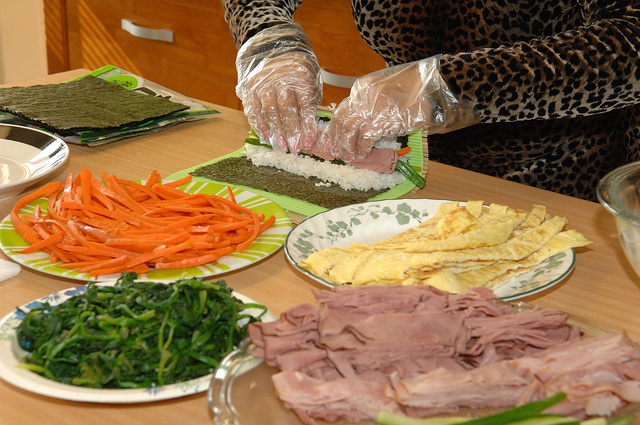Describe the objects in this image and their specific colors. I can see dining table in tan, gray, and olive tones, people in tan, black, gray, and maroon tones, broccoli in tan and darkgreen tones, carrot in tan, red, salmon, olive, and brown tones, and bowl in tan, gray, and olive tones in this image. 